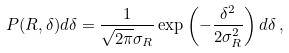Convert formula to latex. <formula><loc_0><loc_0><loc_500><loc_500>P ( R , \delta ) d \delta = \frac { 1 } { \sqrt { 2 \pi } \sigma _ { R } } \exp \left ( - \frac { \delta ^ { 2 } } { 2 \sigma _ { R } ^ { 2 } } \right ) d \delta \, ,</formula> 